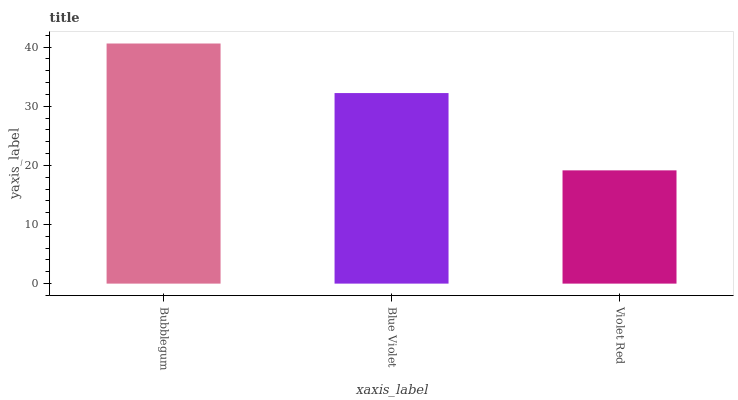Is Blue Violet the minimum?
Answer yes or no. No. Is Blue Violet the maximum?
Answer yes or no. No. Is Bubblegum greater than Blue Violet?
Answer yes or no. Yes. Is Blue Violet less than Bubblegum?
Answer yes or no. Yes. Is Blue Violet greater than Bubblegum?
Answer yes or no. No. Is Bubblegum less than Blue Violet?
Answer yes or no. No. Is Blue Violet the high median?
Answer yes or no. Yes. Is Blue Violet the low median?
Answer yes or no. Yes. Is Violet Red the high median?
Answer yes or no. No. Is Violet Red the low median?
Answer yes or no. No. 